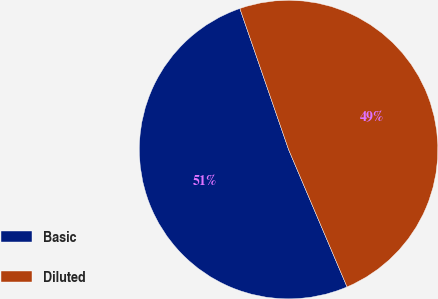Convert chart. <chart><loc_0><loc_0><loc_500><loc_500><pie_chart><fcel>Basic<fcel>Diluted<nl><fcel>51.11%<fcel>48.89%<nl></chart> 